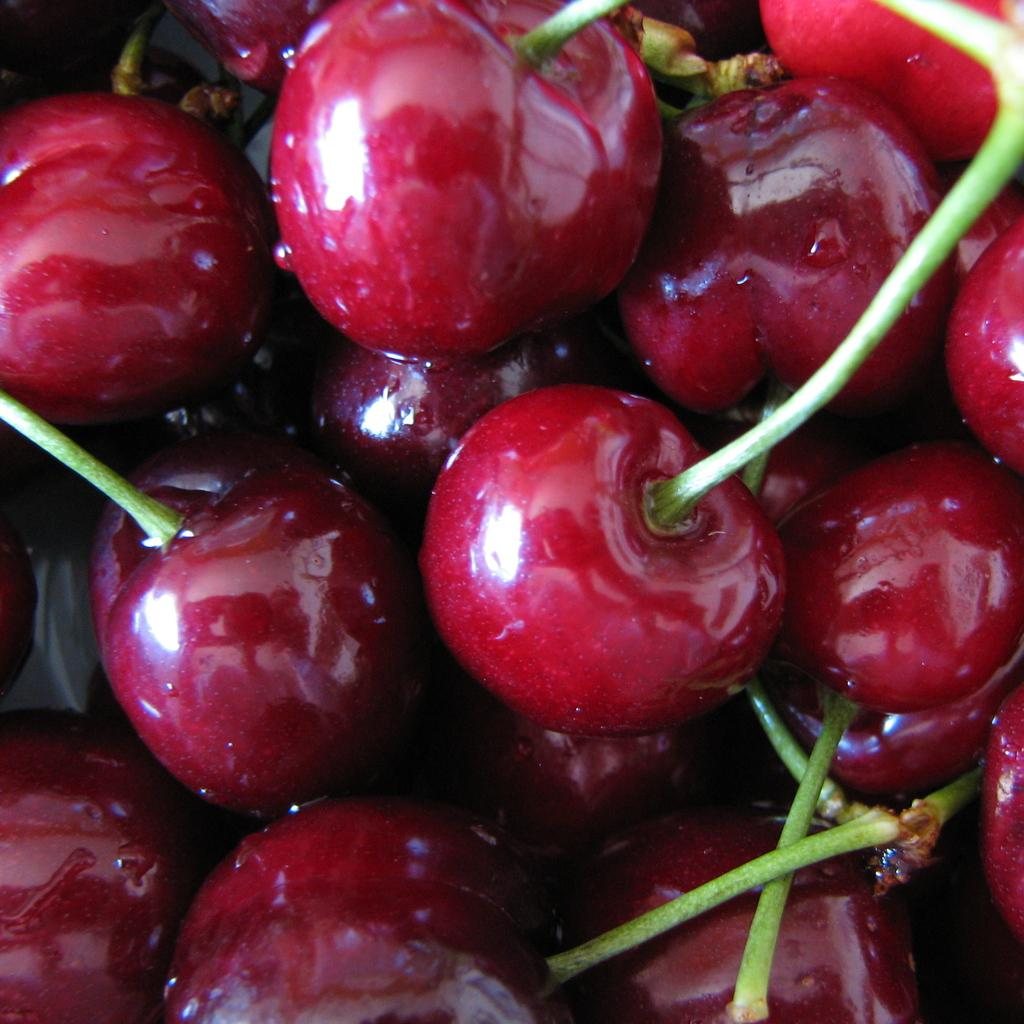What type of fruit can be seen in the image? There are red color berries in the image. Can you describe the color of the berries? The berries are red in color. How many points does the burner have in the image? There is no burner present in the image, as it only features red color berries. 